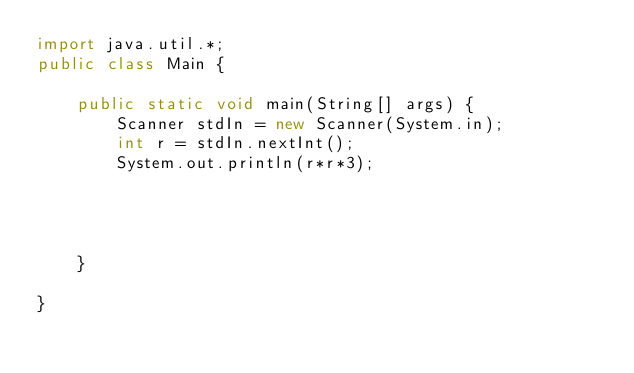<code> <loc_0><loc_0><loc_500><loc_500><_Java_>import java.util.*;
public class Main {

	public static void main(String[] args) {
		Scanner stdIn = new Scanner(System.in);
		int r = stdIn.nextInt();
		System.out.println(r*r*3);
		
		
		
		
	}

}
</code> 